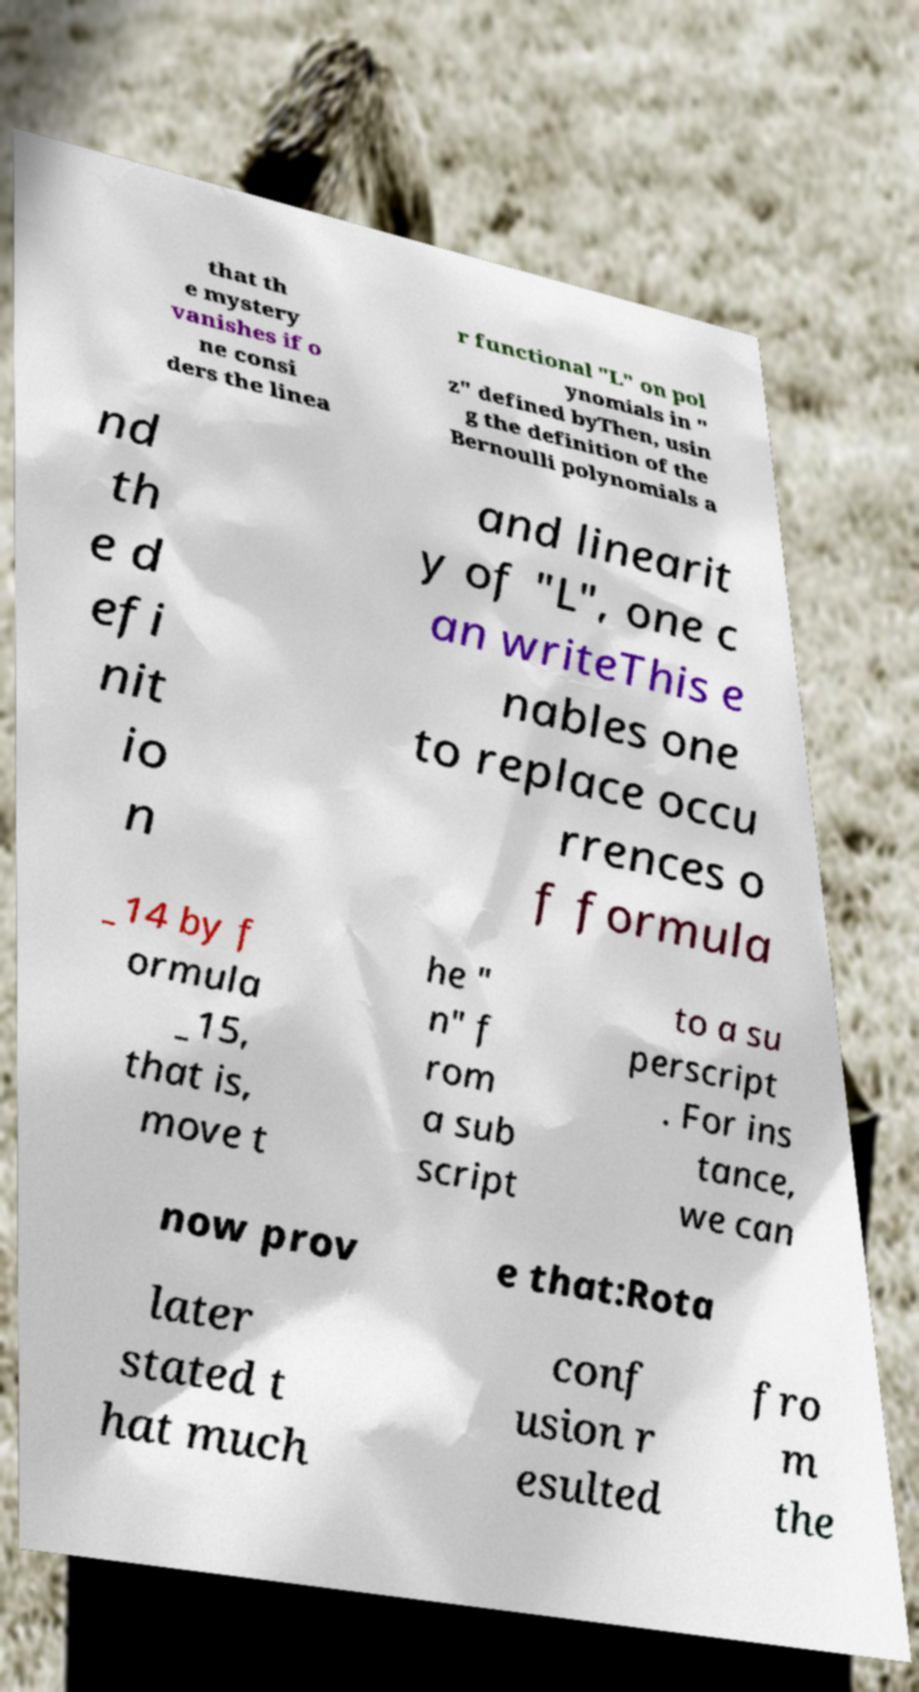Can you accurately transcribe the text from the provided image for me? that th e mystery vanishes if o ne consi ders the linea r functional "L" on pol ynomials in " z" defined byThen, usin g the definition of the Bernoulli polynomials a nd th e d efi nit io n and linearit y of "L", one c an writeThis e nables one to replace occu rrences o f formula _14 by f ormula _15, that is, move t he " n" f rom a sub script to a su perscript . For ins tance, we can now prov e that:Rota later stated t hat much conf usion r esulted fro m the 